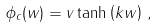Convert formula to latex. <formula><loc_0><loc_0><loc_500><loc_500>\phi _ { c } ( w ) = v \tanh \left ( k w \right ) \, ,</formula> 